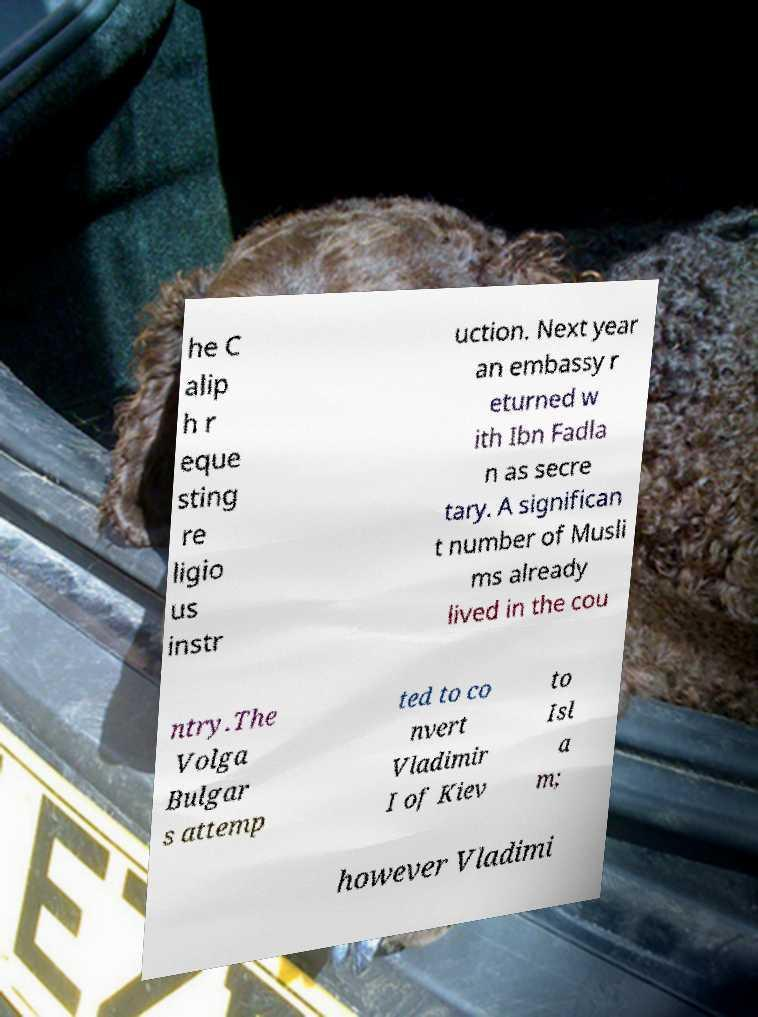I need the written content from this picture converted into text. Can you do that? he C alip h r eque sting re ligio us instr uction. Next year an embassy r eturned w ith Ibn Fadla n as secre tary. A significan t number of Musli ms already lived in the cou ntry.The Volga Bulgar s attemp ted to co nvert Vladimir I of Kiev to Isl a m; however Vladimi 